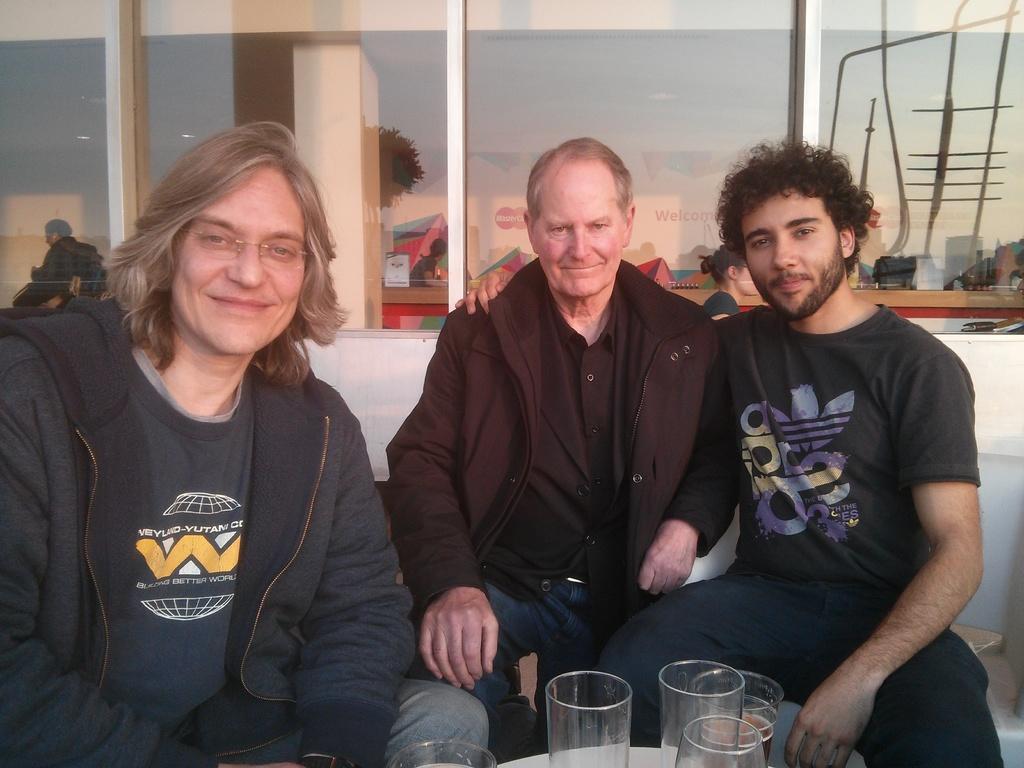How would you summarize this image in a sentence or two? In this picture there are three persons sitting in the foreground. There are glasses on the table. At the back there is a building and there is a reflection of buildings and tree and sky. 